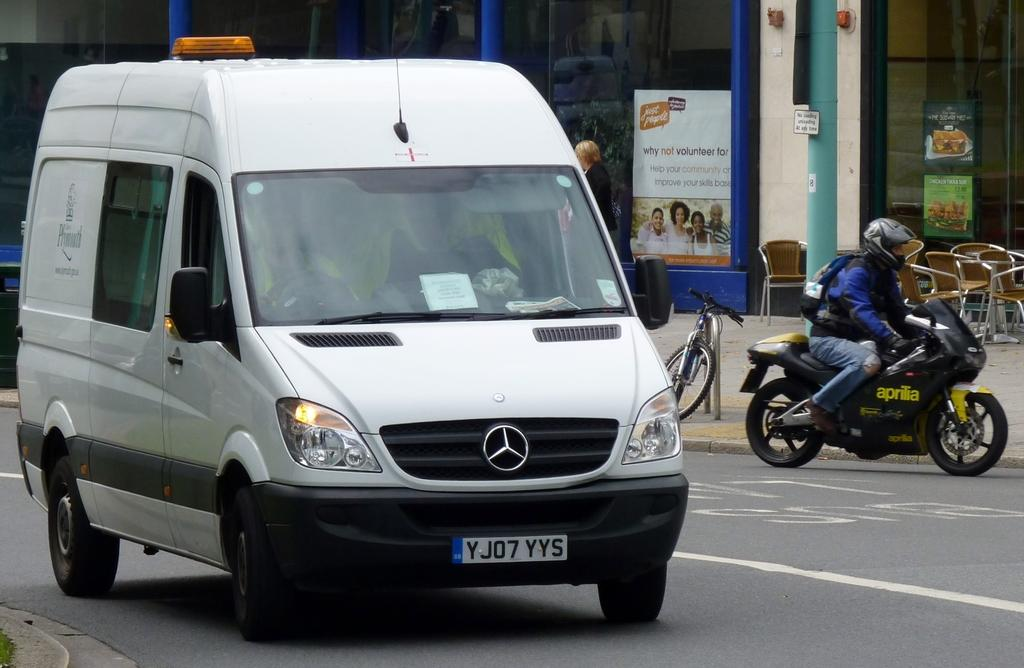<image>
Write a terse but informative summary of the picture. a van that has the letter Y on it 